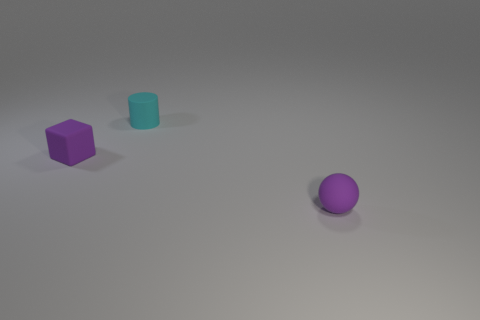Are there fewer matte balls right of the cylinder than matte objects on the right side of the purple rubber sphere?
Provide a short and direct response. No. Is there anything else that is the same size as the matte ball?
Offer a terse response. Yes. The rubber ball has what size?
Ensure brevity in your answer.  Small. What number of small things are rubber blocks or cyan matte balls?
Offer a very short reply. 1. There is a rubber block; is it the same size as the purple object that is on the right side of the small rubber cylinder?
Keep it short and to the point. Yes. Is there any other thing that has the same shape as the tiny cyan object?
Ensure brevity in your answer.  No. What number of large red metallic blocks are there?
Offer a terse response. 0. What number of brown things are big matte cylinders or small rubber objects?
Your answer should be compact. 0. Is the material of the small purple object to the left of the small purple sphere the same as the small ball?
Your answer should be compact. Yes. What is the material of the ball?
Give a very brief answer. Rubber. 